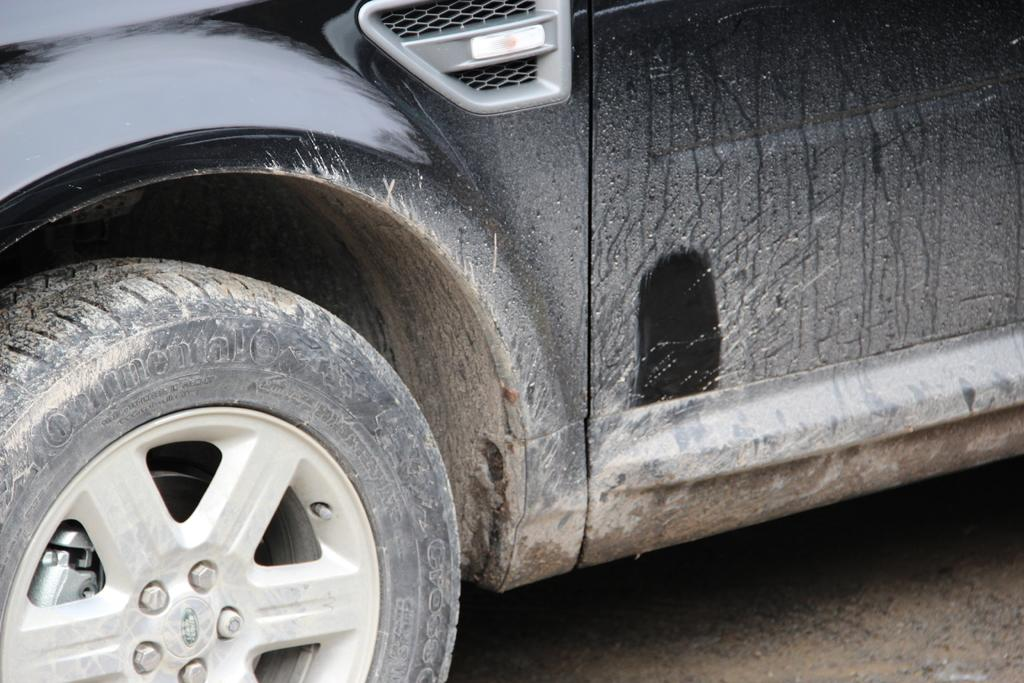What type of vehicle is shown in the image? The image is of a vehicle, specifically a black car. Are there any unique features on the car? Yes, there is text on the wheel of the car. What is visible at the bottom of the image? There is a road at the bottom of the image. How many apples are hanging from the car's rearview mirror in the image? There are no apples present in the image, nor are there any hanging from the car's rearview mirror. 